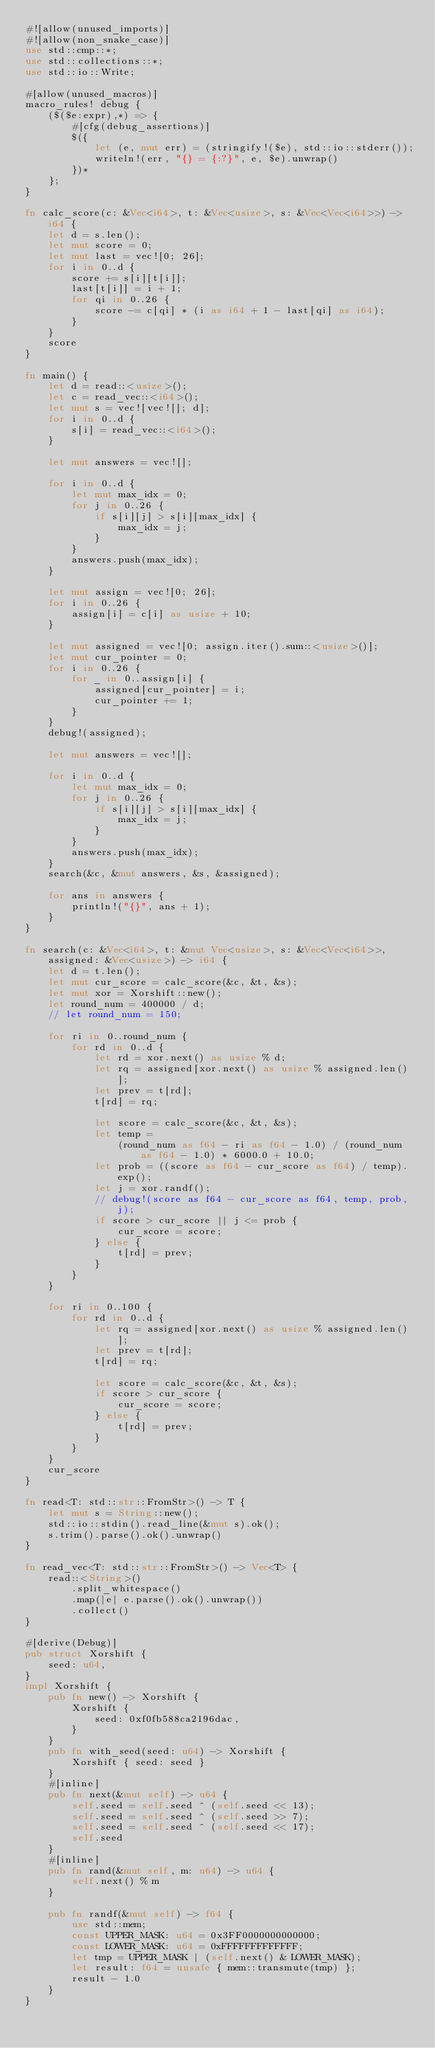Convert code to text. <code><loc_0><loc_0><loc_500><loc_500><_Rust_>#![allow(unused_imports)]
#![allow(non_snake_case)]
use std::cmp::*;
use std::collections::*;
use std::io::Write;

#[allow(unused_macros)]
macro_rules! debug {
    ($($e:expr),*) => {
        #[cfg(debug_assertions)]
        $({
            let (e, mut err) = (stringify!($e), std::io::stderr());
            writeln!(err, "{} = {:?}", e, $e).unwrap()
        })*
    };
}

fn calc_score(c: &Vec<i64>, t: &Vec<usize>, s: &Vec<Vec<i64>>) -> i64 {
    let d = s.len();
    let mut score = 0;
    let mut last = vec![0; 26];
    for i in 0..d {
        score += s[i][t[i]];
        last[t[i]] = i + 1;
        for qi in 0..26 {
            score -= c[qi] * (i as i64 + 1 - last[qi] as i64);
        }
    }
    score
}

fn main() {
    let d = read::<usize>();
    let c = read_vec::<i64>();
    let mut s = vec![vec![]; d];
    for i in 0..d {
        s[i] = read_vec::<i64>();
    }

    let mut answers = vec![];

    for i in 0..d {
        let mut max_idx = 0;
        for j in 0..26 {
            if s[i][j] > s[i][max_idx] {
                max_idx = j;
            }
        }
        answers.push(max_idx);
    }

    let mut assign = vec![0; 26];
    for i in 0..26 {
        assign[i] = c[i] as usize + 10;
    }

    let mut assigned = vec![0; assign.iter().sum::<usize>()];
    let mut cur_pointer = 0;
    for i in 0..26 {
        for _ in 0..assign[i] {
            assigned[cur_pointer] = i;
            cur_pointer += 1;
        }
    }
    debug!(assigned);

    let mut answers = vec![];

    for i in 0..d {
        let mut max_idx = 0;
        for j in 0..26 {
            if s[i][j] > s[i][max_idx] {
                max_idx = j;
            }
        }
        answers.push(max_idx);
    }
    search(&c, &mut answers, &s, &assigned);

    for ans in answers {
        println!("{}", ans + 1);
    }
}

fn search(c: &Vec<i64>, t: &mut Vec<usize>, s: &Vec<Vec<i64>>, assigned: &Vec<usize>) -> i64 {
    let d = t.len();
    let mut cur_score = calc_score(&c, &t, &s);
    let mut xor = Xorshift::new();
    let round_num = 400000 / d;
    // let round_num = 150;

    for ri in 0..round_num {
        for rd in 0..d {
            let rd = xor.next() as usize % d;
            let rq = assigned[xor.next() as usize % assigned.len()];
            let prev = t[rd];
            t[rd] = rq;

            let score = calc_score(&c, &t, &s);
            let temp =
                (round_num as f64 - ri as f64 - 1.0) / (round_num as f64 - 1.0) * 6000.0 + 10.0;
            let prob = ((score as f64 - cur_score as f64) / temp).exp();
            let j = xor.randf();
            // debug!(score as f64 - cur_score as f64, temp, prob, j);
            if score > cur_score || j <= prob {
                cur_score = score;
            } else {
                t[rd] = prev;
            }
        }
    }

    for ri in 0..100 {
        for rd in 0..d {
            let rq = assigned[xor.next() as usize % assigned.len()];
            let prev = t[rd];
            t[rd] = rq;

            let score = calc_score(&c, &t, &s);
            if score > cur_score {
                cur_score = score;
            } else {
                t[rd] = prev;
            }
        }
    }
    cur_score
}

fn read<T: std::str::FromStr>() -> T {
    let mut s = String::new();
    std::io::stdin().read_line(&mut s).ok();
    s.trim().parse().ok().unwrap()
}

fn read_vec<T: std::str::FromStr>() -> Vec<T> {
    read::<String>()
        .split_whitespace()
        .map(|e| e.parse().ok().unwrap())
        .collect()
}

#[derive(Debug)]
pub struct Xorshift {
    seed: u64,
}
impl Xorshift {
    pub fn new() -> Xorshift {
        Xorshift {
            seed: 0xf0fb588ca2196dac,
        }
    }
    pub fn with_seed(seed: u64) -> Xorshift {
        Xorshift { seed: seed }
    }
    #[inline]
    pub fn next(&mut self) -> u64 {
        self.seed = self.seed ^ (self.seed << 13);
        self.seed = self.seed ^ (self.seed >> 7);
        self.seed = self.seed ^ (self.seed << 17);
        self.seed
    }
    #[inline]
    pub fn rand(&mut self, m: u64) -> u64 {
        self.next() % m
    }

    pub fn randf(&mut self) -> f64 {
        use std::mem;
        const UPPER_MASK: u64 = 0x3FF0000000000000;
        const LOWER_MASK: u64 = 0xFFFFFFFFFFFFF;
        let tmp = UPPER_MASK | (self.next() & LOWER_MASK);
        let result: f64 = unsafe { mem::transmute(tmp) };
        result - 1.0
    }
}
</code> 